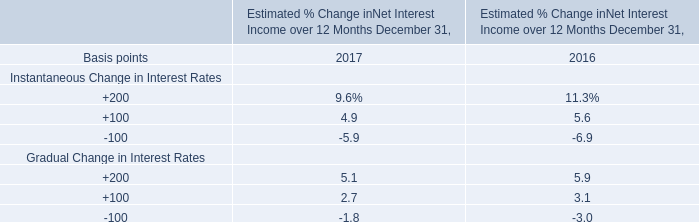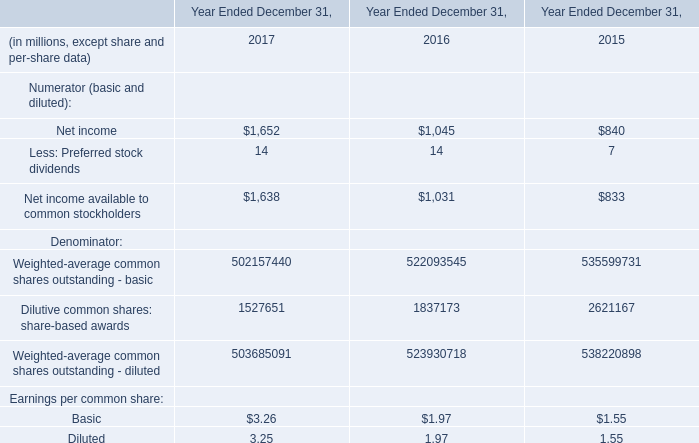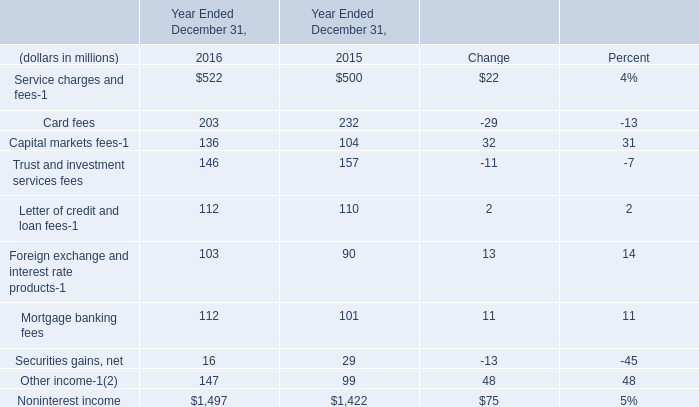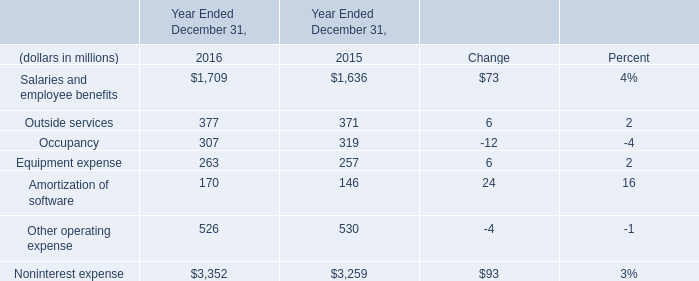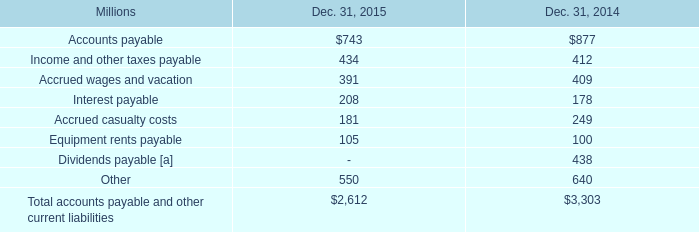What will Service charges and fees be like in 2017 if it develops with the same increasing rate as current? (in million) 
Computations: (522 * (1 + ((522 - 500) / 500)))
Answer: 544.968. 